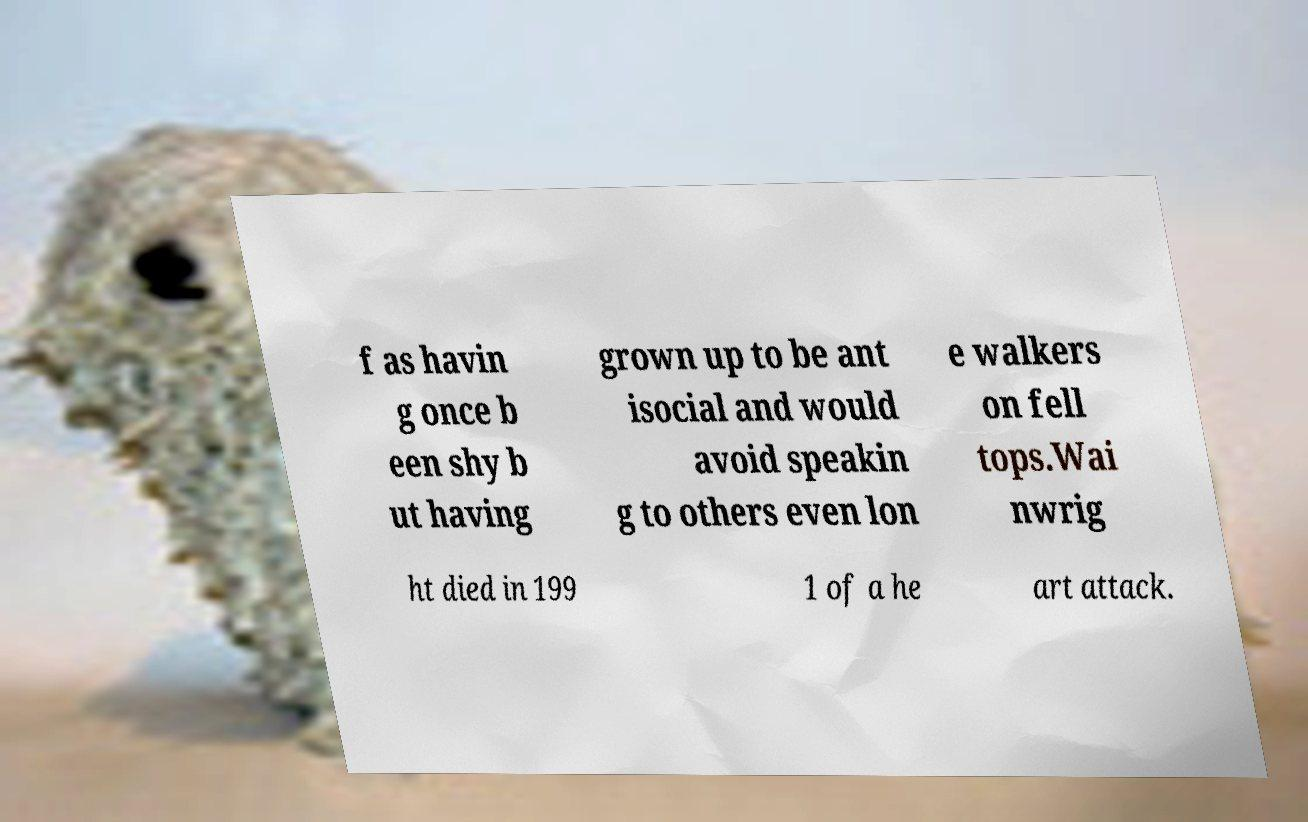Please read and relay the text visible in this image. What does it say? f as havin g once b een shy b ut having grown up to be ant isocial and would avoid speakin g to others even lon e walkers on fell tops.Wai nwrig ht died in 199 1 of a he art attack. 